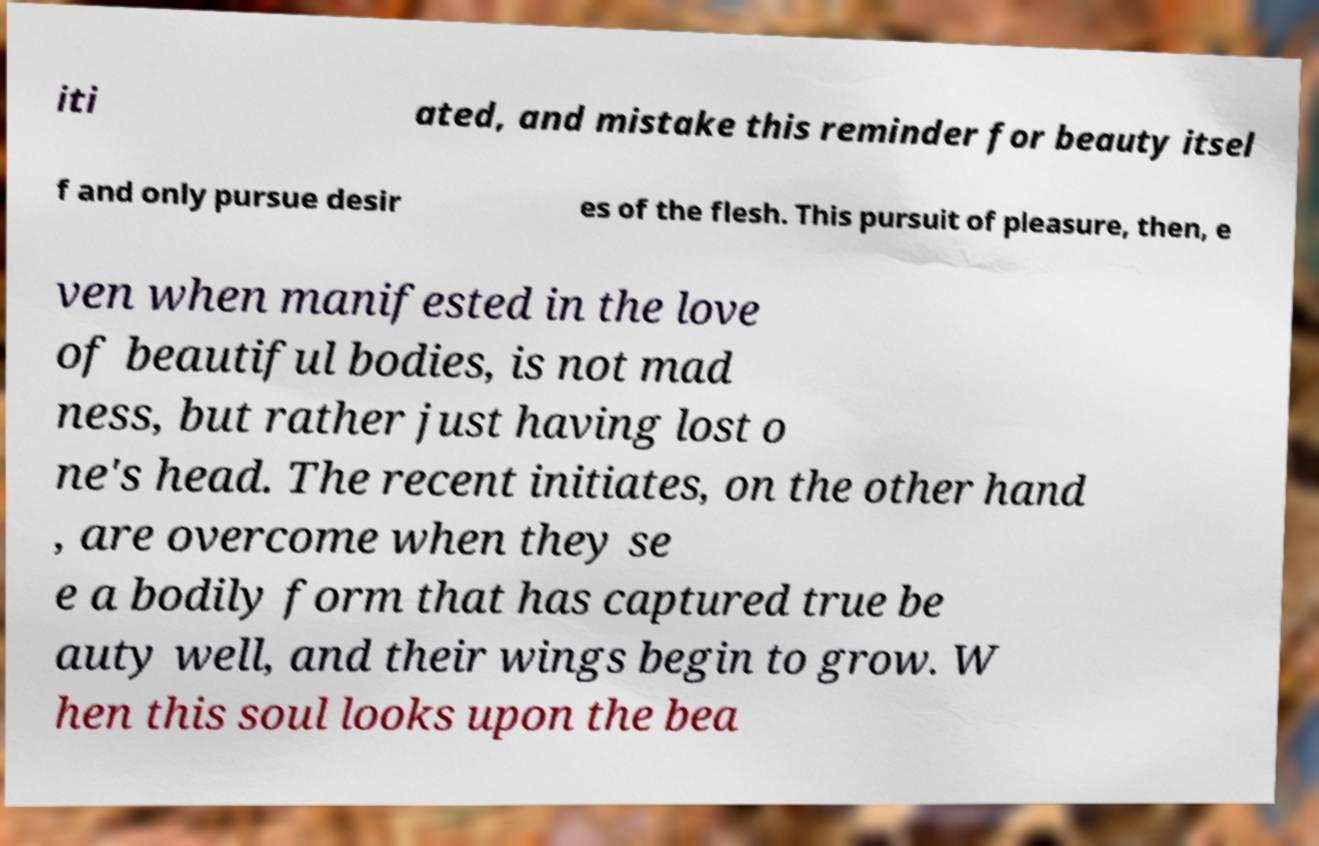Please identify and transcribe the text found in this image. iti ated, and mistake this reminder for beauty itsel f and only pursue desir es of the flesh. This pursuit of pleasure, then, e ven when manifested in the love of beautiful bodies, is not mad ness, but rather just having lost o ne's head. The recent initiates, on the other hand , are overcome when they se e a bodily form that has captured true be auty well, and their wings begin to grow. W hen this soul looks upon the bea 